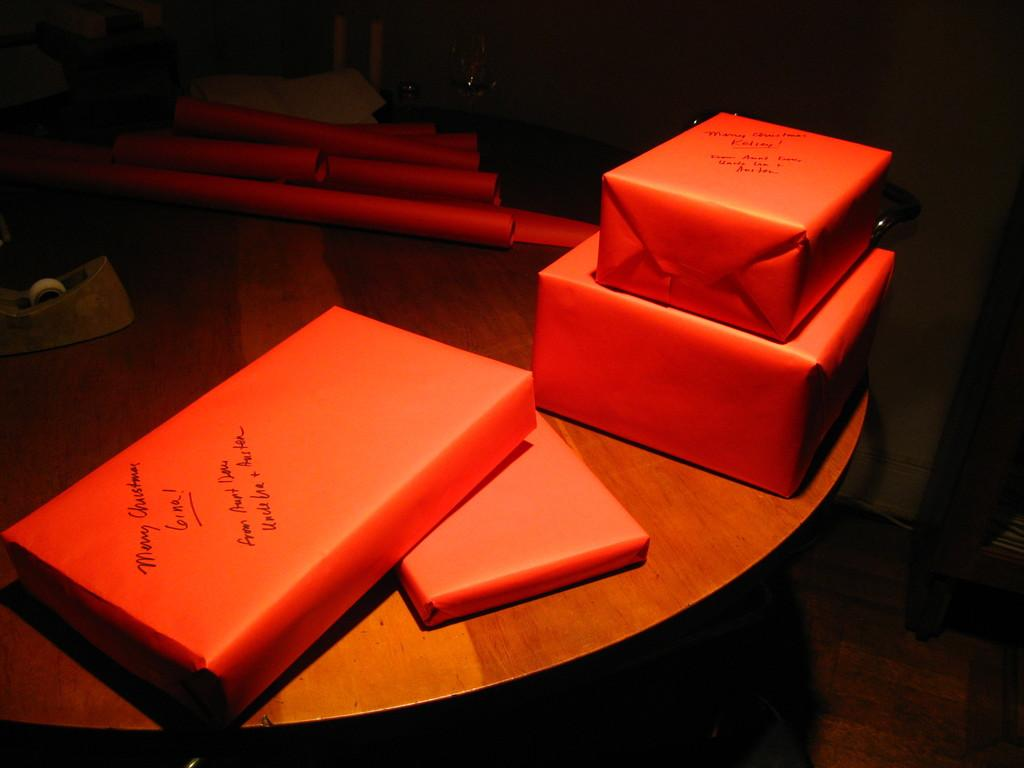<image>
Offer a succinct explanation of the picture presented. Orange presents with the message Merry Christmas written on them. 